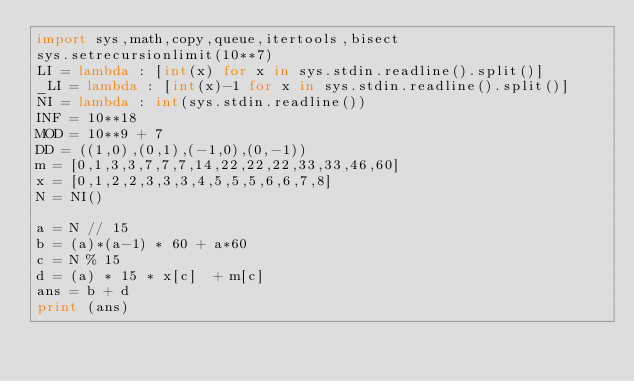Convert code to text. <code><loc_0><loc_0><loc_500><loc_500><_Python_>import sys,math,copy,queue,itertools,bisect
sys.setrecursionlimit(10**7)
LI = lambda : [int(x) for x in sys.stdin.readline().split()]
_LI = lambda : [int(x)-1 for x in sys.stdin.readline().split()]
NI = lambda : int(sys.stdin.readline())
INF = 10**18
MOD = 10**9 + 7
DD = ((1,0),(0,1),(-1,0),(0,-1))
m = [0,1,3,3,7,7,7,14,22,22,22,33,33,46,60]
x = [0,1,2,2,3,3,3,4,5,5,5,6,6,7,8]
N = NI()

a = N // 15
b = (a)*(a-1) * 60 + a*60
c = N % 15
d = (a) * 15 * x[c]  + m[c]
ans = b + d
print (ans)</code> 